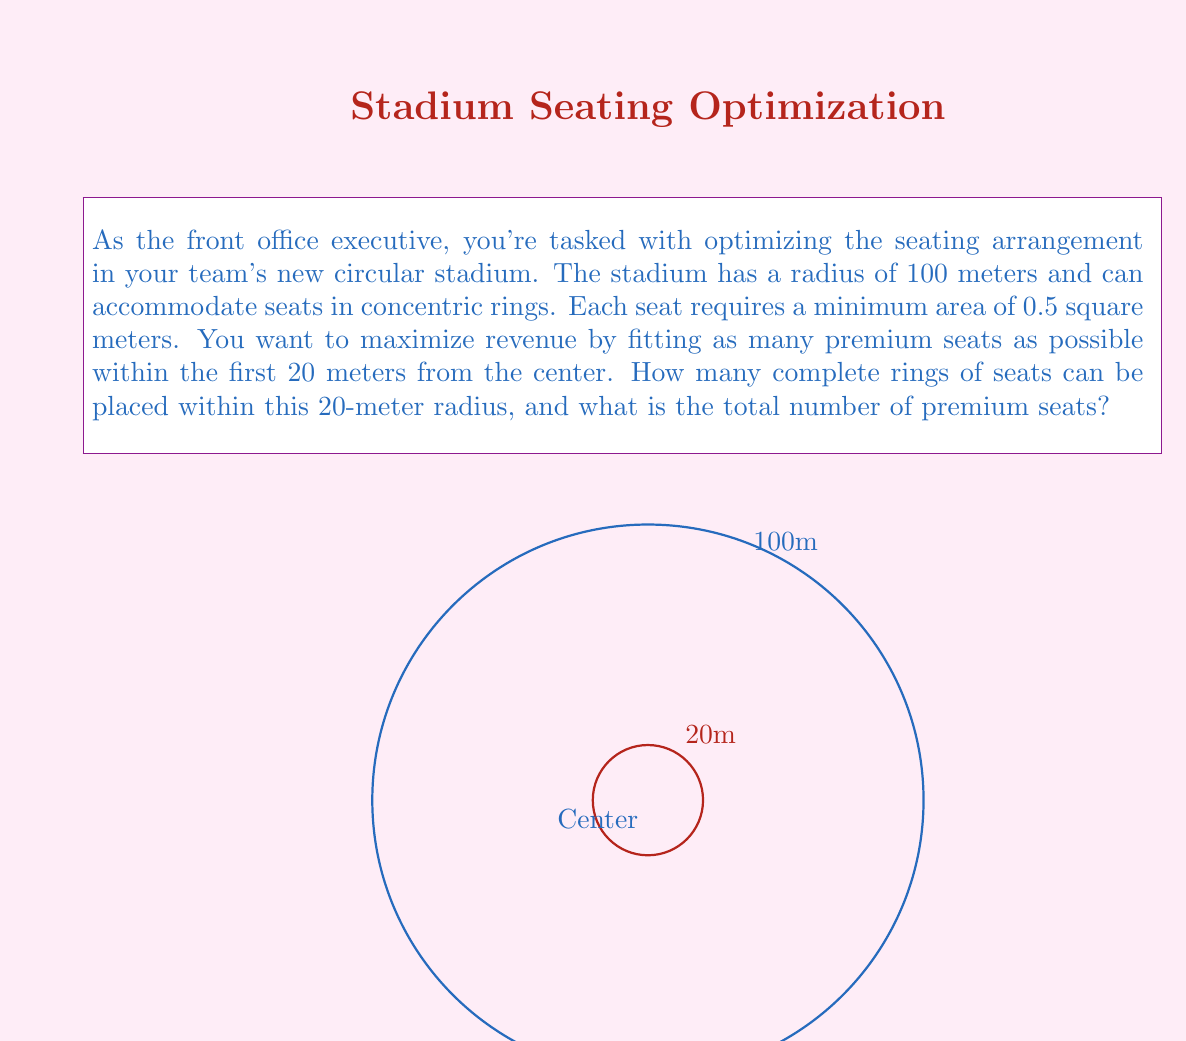Help me with this question. Let's approach this step-by-step using polar coordinates:

1) In polar coordinates, the area of a circular ring between radii $r_1$ and $r_2$ is given by:
   $$A = \pi(r_2^2 - r_1^2)$$

2) Each seat requires 0.5 square meters. In polar coordinates, this translates to:
   $$0.5 = \pi(r_{n+1}^2 - r_n^2)$$
   where $r_n$ is the radius of the nth ring.

3) Solving for $r_{n+1}$:
   $$r_{n+1} = \sqrt{r_n^2 + \frac{0.5}{\pi}}$$

4) Starting with $r_0 = 0$ (center of the stadium), we can calculate successive radii:
   $$r_1 = \sqrt{0^2 + \frac{0.5}{\pi}} \approx 0.3989$$
   $$r_2 = \sqrt{0.3989^2 + \frac{0.5}{\pi}} \approx 0.5641$$
   $$r_3 = \sqrt{0.5641^2 + \frac{0.5}{\pi}} \approx 0.6904$$
   ...

5) We continue this process until we reach a radius that exceeds 20 meters. This occurs at the 50th ring, where $r_{50} \approx 19.9475$ and $r_{51} \approx 20.0251$.

6) Therefore, we can fit 50 complete rings of seats within the 20-meter radius.

7) To calculate the total number of seats, we need to find the circumference of each ring and divide by the width of a seat. The width of a seat is approximately $\sqrt{0.5} \approx 0.7071$ meters.

8) The number of seats in the nth ring is given by:
   $$\text{Seats}_n = \frac{2\pi r_n}{0.7071}$$

9) Summing this for all 50 rings gives us the total number of premium seats.

10) Using a computer to perform this calculation, we get approximately 8,835 seats.
Answer: 50 rings, 8,835 seats 